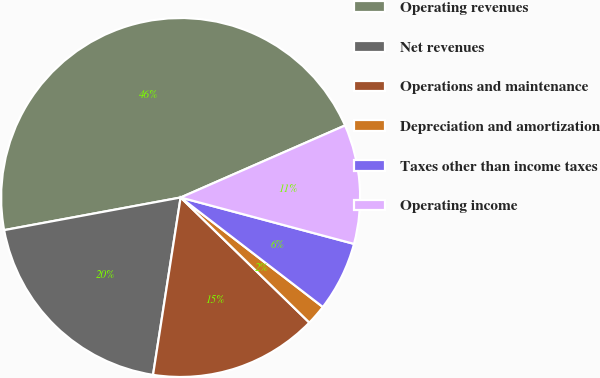Convert chart to OTSL. <chart><loc_0><loc_0><loc_500><loc_500><pie_chart><fcel>Operating revenues<fcel>Net revenues<fcel>Operations and maintenance<fcel>Depreciation and amortization<fcel>Taxes other than income taxes<fcel>Operating income<nl><fcel>46.33%<fcel>19.63%<fcel>15.18%<fcel>1.83%<fcel>6.28%<fcel>10.73%<nl></chart> 